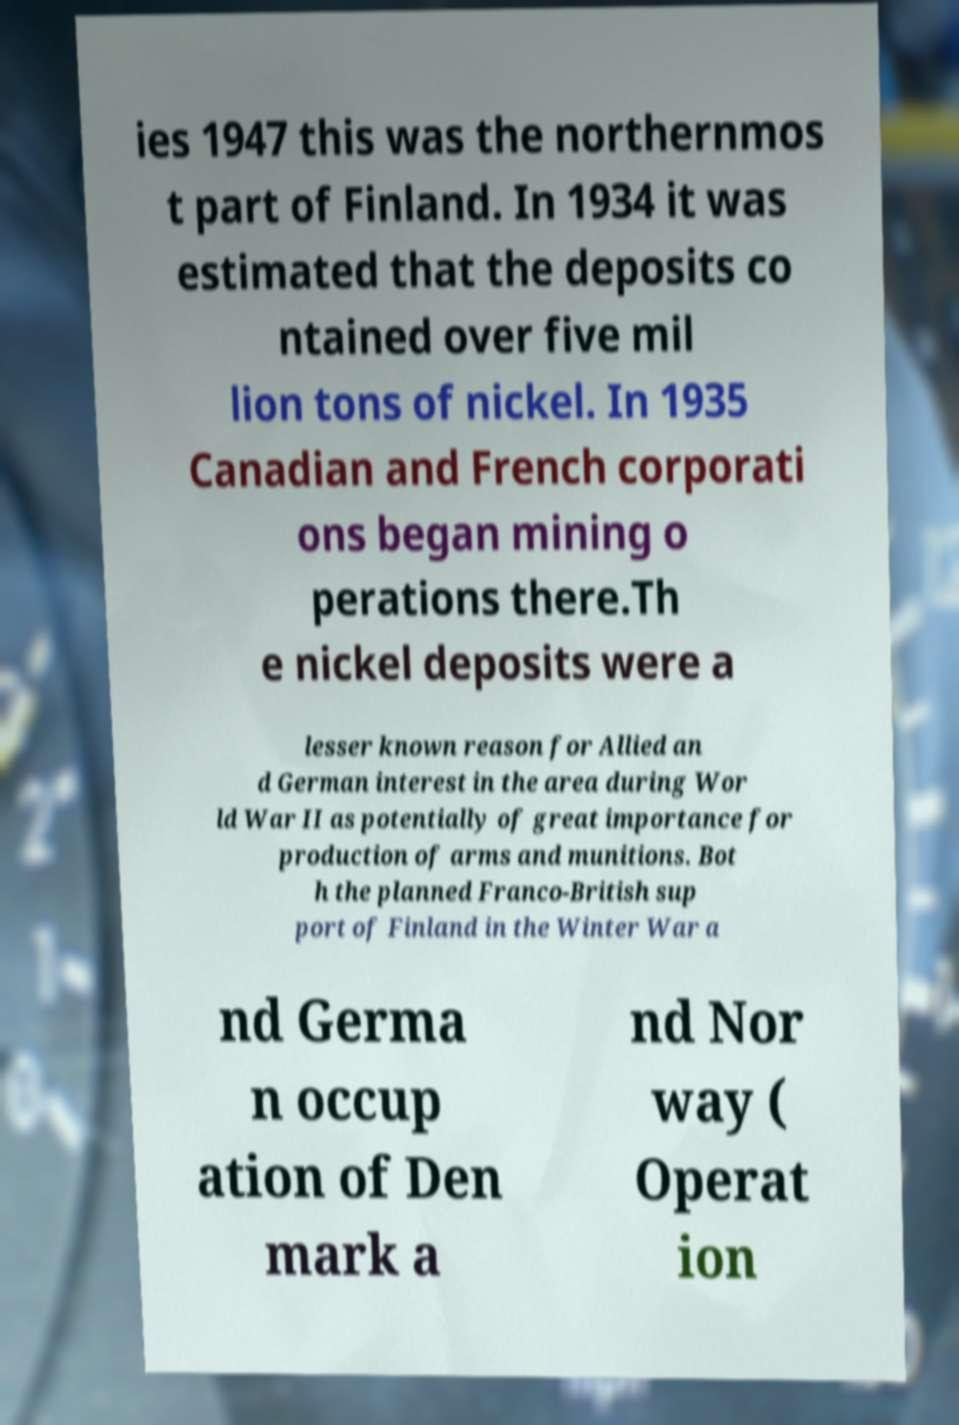There's text embedded in this image that I need extracted. Can you transcribe it verbatim? ies 1947 this was the northernmos t part of Finland. In 1934 it was estimated that the deposits co ntained over five mil lion tons of nickel. In 1935 Canadian and French corporati ons began mining o perations there.Th e nickel deposits were a lesser known reason for Allied an d German interest in the area during Wor ld War II as potentially of great importance for production of arms and munitions. Bot h the planned Franco-British sup port of Finland in the Winter War a nd Germa n occup ation of Den mark a nd Nor way ( Operat ion 